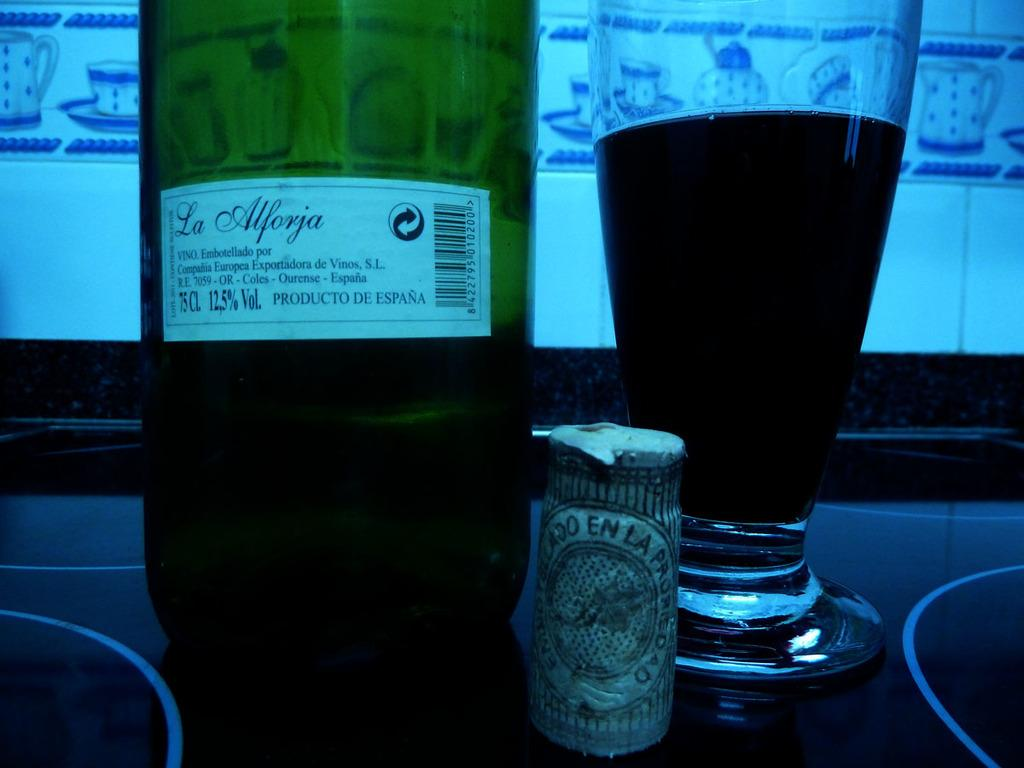What object in the image contains a liquid? The bottle and the glass in the image both contain a liquid. What is the purpose of the glass in the image? The purpose of the glass in the image is to hold the liquid. What is the color of the liquid in the bottle? The color of the liquid in the bottle cannot be determined from the image. What type of polish is being applied to the zoo animals in the image? There is no polish or zoo animals present in the image. 